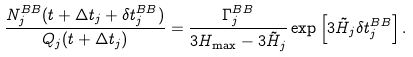<formula> <loc_0><loc_0><loc_500><loc_500>\frac { N _ { j } ^ { B B } ( t + \Delta t _ { j } + \delta t _ { j } ^ { B B } ) } { Q _ { j } ( t + \Delta t _ { j } ) } = \frac { \Gamma _ { j } ^ { B B } } { 3 H _ { \max } - 3 \tilde { H } _ { j } } \exp \left [ 3 \tilde { H } _ { j } \delta t _ { j } ^ { B B } \right ] .</formula> 